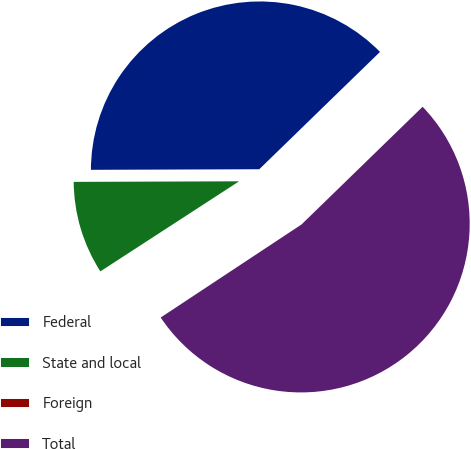Convert chart to OTSL. <chart><loc_0><loc_0><loc_500><loc_500><pie_chart><fcel>Federal<fcel>State and local<fcel>Foreign<fcel>Total<nl><fcel>37.78%<fcel>9.11%<fcel>0.13%<fcel>52.98%<nl></chart> 